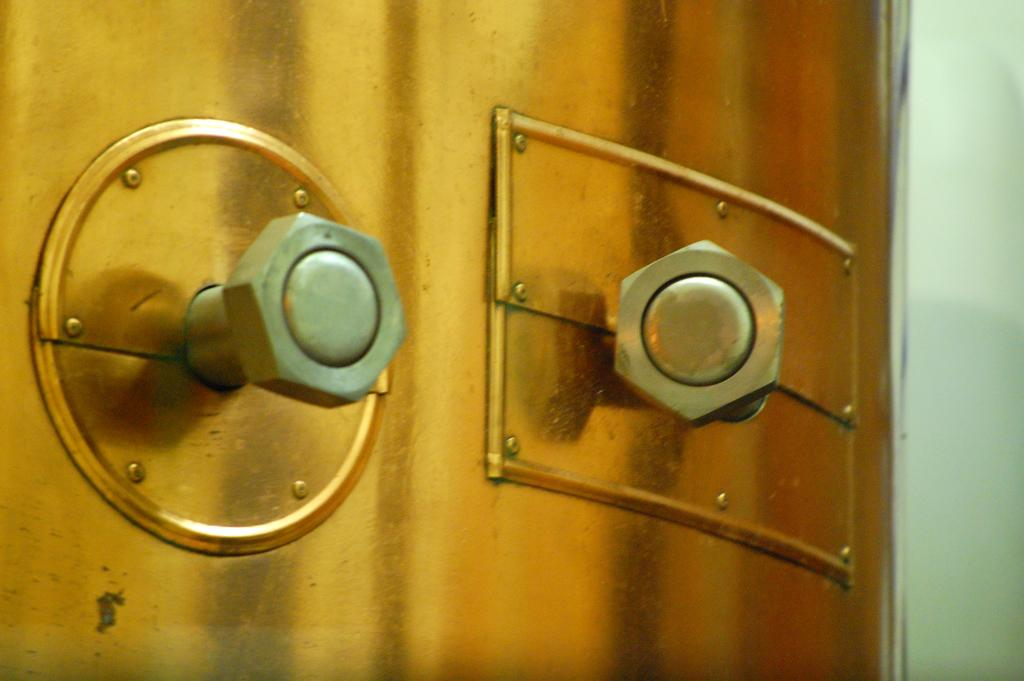What type of structure can be seen in the image? There is a door and a wall in the image. What feature can be observed on the door? The door has bolts. Can you see a frog sitting on the wall in the image? No, there is no frog present in the image. What type of rock is used to build the wall in the image? The image does not provide information about the type of rock used to build the wall. 